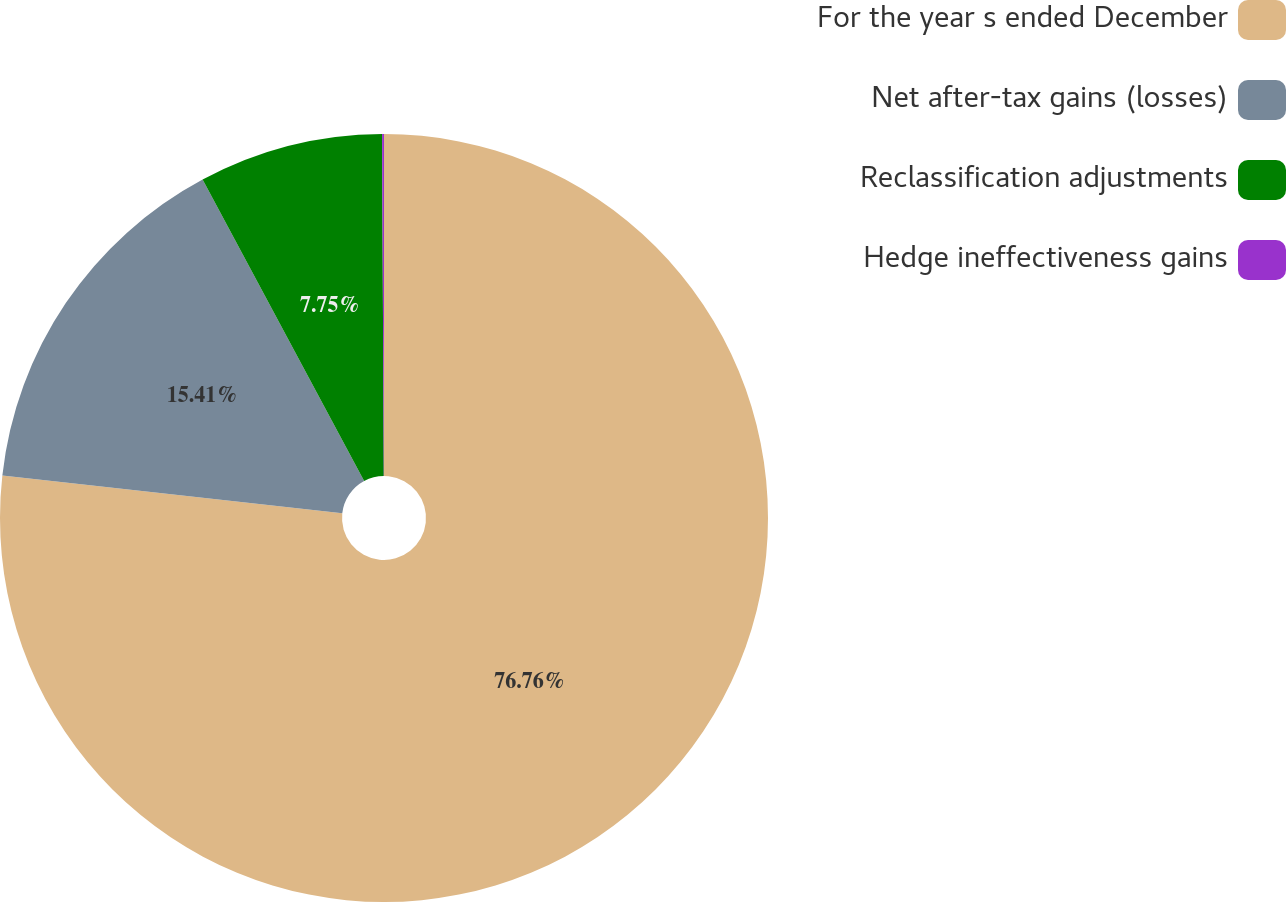<chart> <loc_0><loc_0><loc_500><loc_500><pie_chart><fcel>For the year s ended December<fcel>Net after-tax gains (losses)<fcel>Reclassification adjustments<fcel>Hedge ineffectiveness gains<nl><fcel>76.76%<fcel>15.41%<fcel>7.75%<fcel>0.08%<nl></chart> 